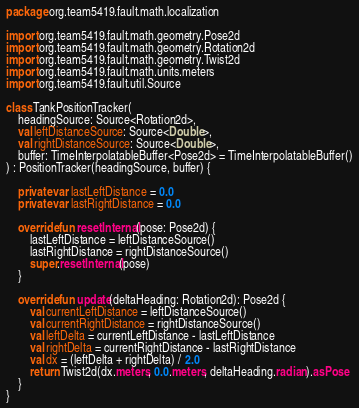Convert code to text. <code><loc_0><loc_0><loc_500><loc_500><_Kotlin_>package org.team5419.fault.math.localization

import org.team5419.fault.math.geometry.Pose2d
import org.team5419.fault.math.geometry.Rotation2d
import org.team5419.fault.math.geometry.Twist2d
import org.team5419.fault.math.units.meters
import org.team5419.fault.util.Source

class TankPositionTracker(
    headingSource: Source<Rotation2d>,
    val leftDistanceSource: Source<Double>,
    val rightDistanceSource: Source<Double>,
    buffer: TimeInterpolatableBuffer<Pose2d> = TimeInterpolatableBuffer()
) : PositionTracker(headingSource, buffer) {

    private var lastLeftDistance = 0.0
    private var lastRightDistance = 0.0

    override fun resetInternal(pose: Pose2d) {
        lastLeftDistance = leftDistanceSource()
        lastRightDistance = rightDistanceSource()
        super.resetInternal(pose)
    }

    override fun update(deltaHeading: Rotation2d): Pose2d {
        val currentLeftDistance = leftDistanceSource()
        val currentRightDistance = rightDistanceSource()
        val leftDelta = currentLeftDistance - lastLeftDistance
        val rightDelta = currentRightDistance - lastRightDistance
        val dx = (leftDelta + rightDelta) / 2.0
        return Twist2d(dx.meters, 0.0.meters, deltaHeading.radian).asPose
    }
}
</code> 